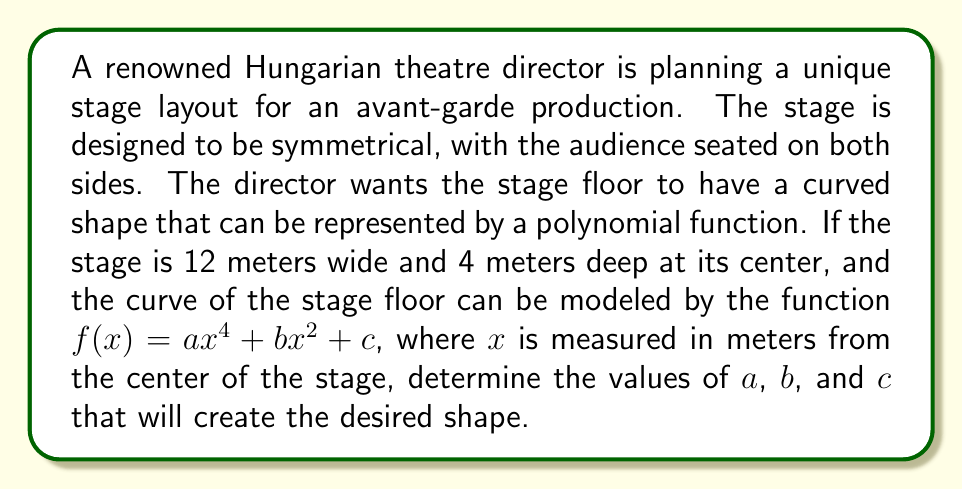Provide a solution to this math problem. To solve this problem, we need to analyze the symmetry of the polynomial function and use the given information about the stage dimensions. Let's approach this step-by-step:

1) The function $f(x) = ax^4 + bx^2 + c$ is an even function, which means it's symmetrical about the y-axis. This matches the symmetrical stage design requirement.

2) We know that the stage is 12 meters wide, so the x-coordinate ranges from -6 to 6 meters.

3) At the center of the stage (x = 0), the depth is 4 meters. This gives us our first equation:
   $f(0) = c = 4$

4) At the edges of the stage (x = ±6), the depth should be 0. This gives us our second equation:
   $f(6) = a(6^4) + b(6^2) + 4 = 0$
   $1296a + 36b + 4 = 0$

5) To ensure a smooth curve that doesn't dip below the stage level, we want the derivative to be zero at x = 0. The derivative of $f(x)$ is:
   $f'(x) = 4ax^3 + 2bx$
   Setting this to zero at x = 0:
   $f'(0) = 0$ (this is automatically satisfied due to the symmetry)

6) To create a gentle curve, let's set the second derivative at x = 0 to a small negative value, say -0.1:
   $f''(x) = 12ax^2 + 2b$
   $f''(0) = 2b = -0.1$
   $b = -0.05$

7) Now we can substitute this value of $b$ into the equation from step 4:
   $1296a + 36(-0.05) + 4 = 0$
   $1296a - 1.8 + 4 = 0$
   $1296a = -2.2$
   $a = -0.001697530864197531$

Therefore, we have:
$a ≈ -0.0017$
$b = -0.05$
$c = 4$
Answer: The polynomial function representing the stage floor curve is approximately:
$f(x) = -0.0017x^4 - 0.05x^2 + 4$, where $x$ is measured in meters from the center of the stage. 